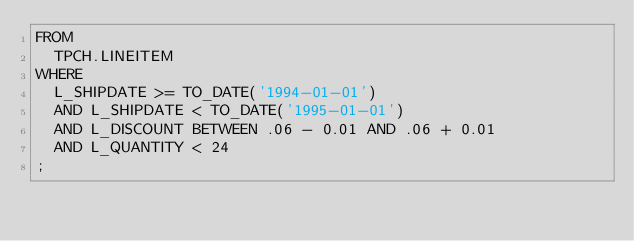<code> <loc_0><loc_0><loc_500><loc_500><_SQL_>FROM
  TPCH.LINEITEM
WHERE
  L_SHIPDATE >= TO_DATE('1994-01-01')
  AND L_SHIPDATE < TO_DATE('1995-01-01')
  AND L_DISCOUNT BETWEEN .06 - 0.01 AND .06 + 0.01
  AND L_QUANTITY < 24
;
</code> 